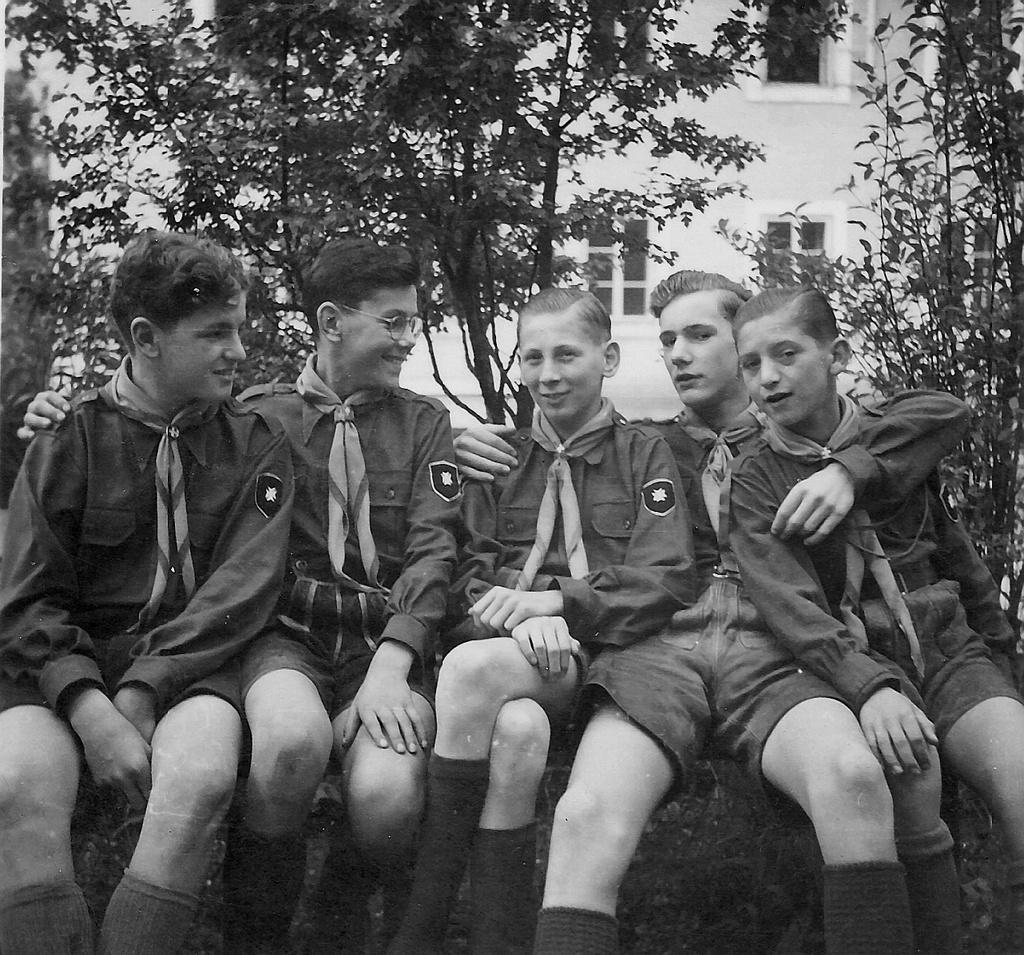What is the color scheme of the image? The image is black and white. What can be seen in the center of the image? There are people sitting in the center of the image. What type of natural environment is visible in the background of the image? There are trees in the background of the image. What type of structure can be seen in the background of the image? There is a building in the background of the image. What book is being read by the people in the image? There is no book present in the image; it is a black and white image of people sitting in the center with trees and a building in the background. 